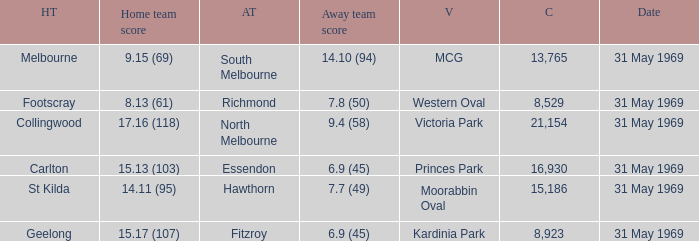What was the highest crowd in Victoria Park? 21154.0. Write the full table. {'header': ['HT', 'Home team score', 'AT', 'Away team score', 'V', 'C', 'Date'], 'rows': [['Melbourne', '9.15 (69)', 'South Melbourne', '14.10 (94)', 'MCG', '13,765', '31 May 1969'], ['Footscray', '8.13 (61)', 'Richmond', '7.8 (50)', 'Western Oval', '8,529', '31 May 1969'], ['Collingwood', '17.16 (118)', 'North Melbourne', '9.4 (58)', 'Victoria Park', '21,154', '31 May 1969'], ['Carlton', '15.13 (103)', 'Essendon', '6.9 (45)', 'Princes Park', '16,930', '31 May 1969'], ['St Kilda', '14.11 (95)', 'Hawthorn', '7.7 (49)', 'Moorabbin Oval', '15,186', '31 May 1969'], ['Geelong', '15.17 (107)', 'Fitzroy', '6.9 (45)', 'Kardinia Park', '8,923', '31 May 1969']]} 